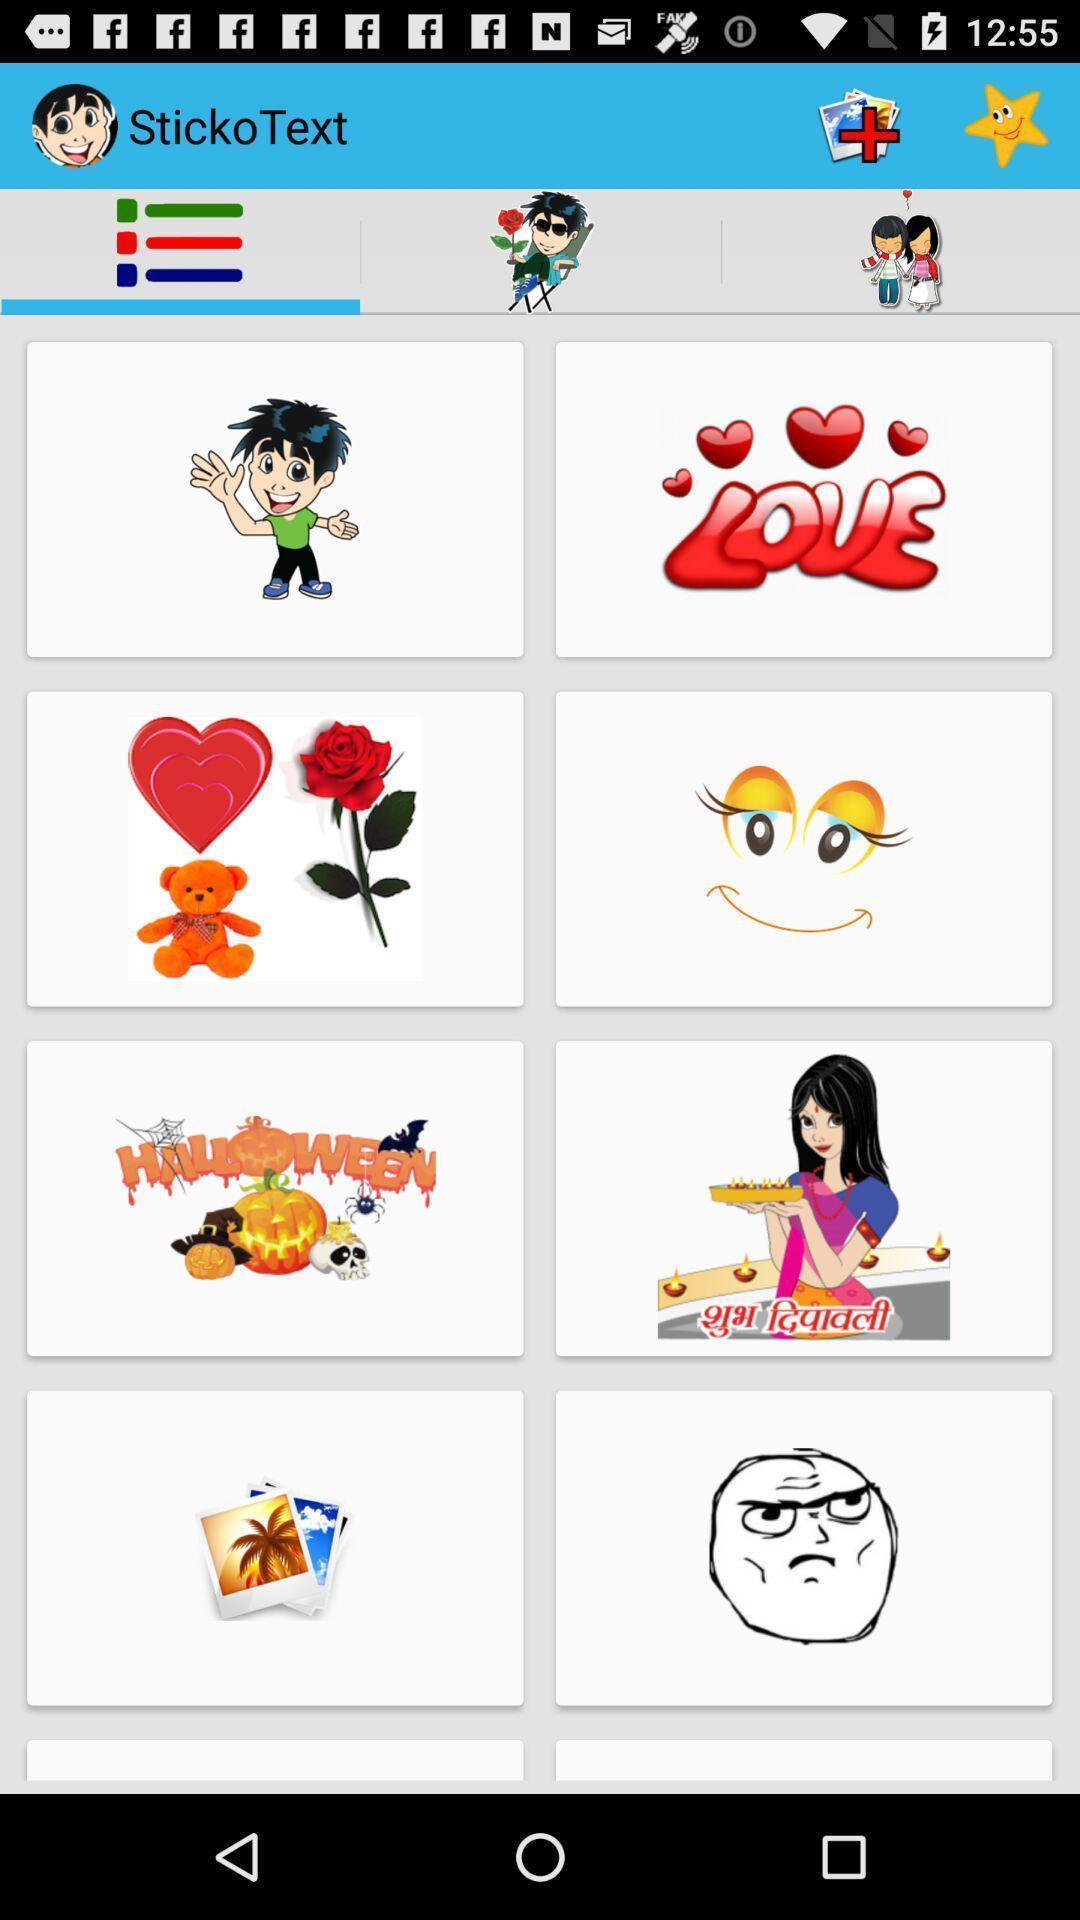Summarize the main components in this picture. Page displaying various stickers. 